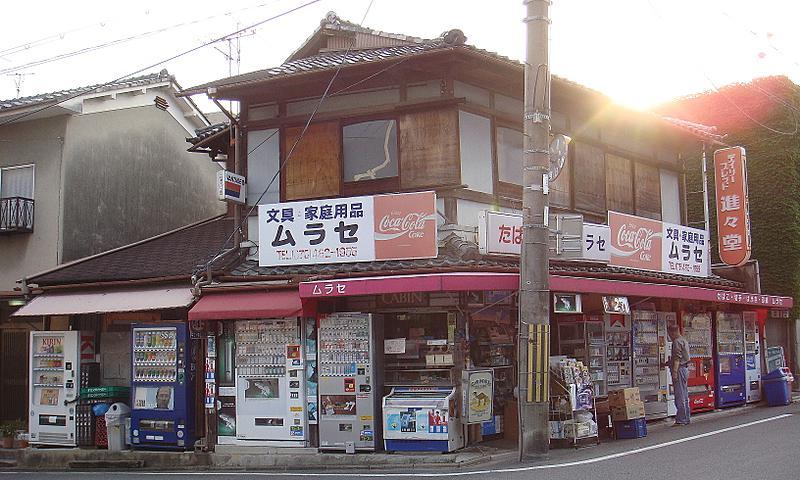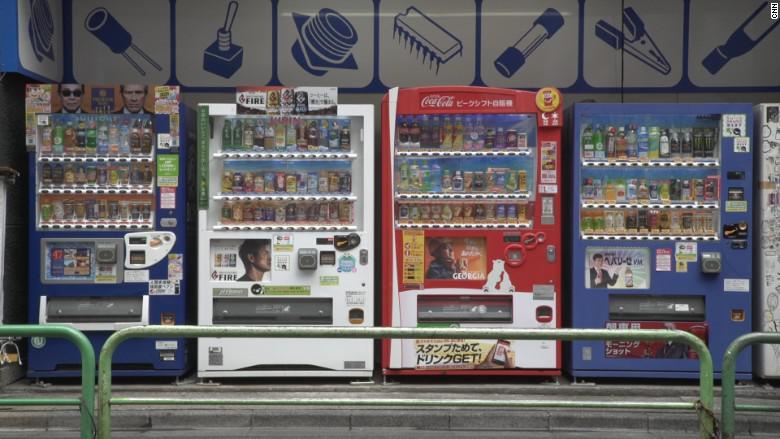The first image is the image on the left, the second image is the image on the right. Assess this claim about the two images: "there are no humans in front of the vending machine". Correct or not? Answer yes or no. Yes. 